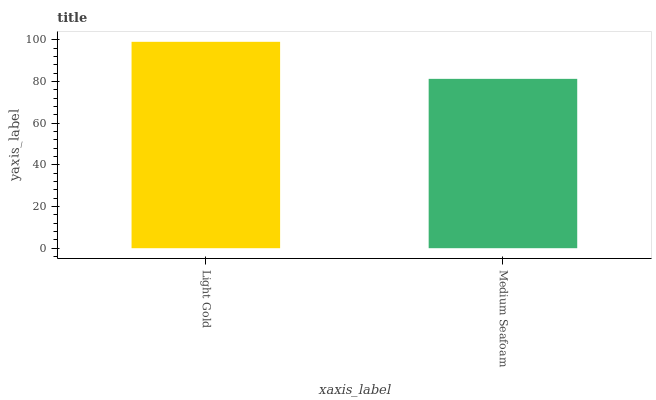Is Medium Seafoam the minimum?
Answer yes or no. Yes. Is Light Gold the maximum?
Answer yes or no. Yes. Is Medium Seafoam the maximum?
Answer yes or no. No. Is Light Gold greater than Medium Seafoam?
Answer yes or no. Yes. Is Medium Seafoam less than Light Gold?
Answer yes or no. Yes. Is Medium Seafoam greater than Light Gold?
Answer yes or no. No. Is Light Gold less than Medium Seafoam?
Answer yes or no. No. Is Light Gold the high median?
Answer yes or no. Yes. Is Medium Seafoam the low median?
Answer yes or no. Yes. Is Medium Seafoam the high median?
Answer yes or no. No. Is Light Gold the low median?
Answer yes or no. No. 